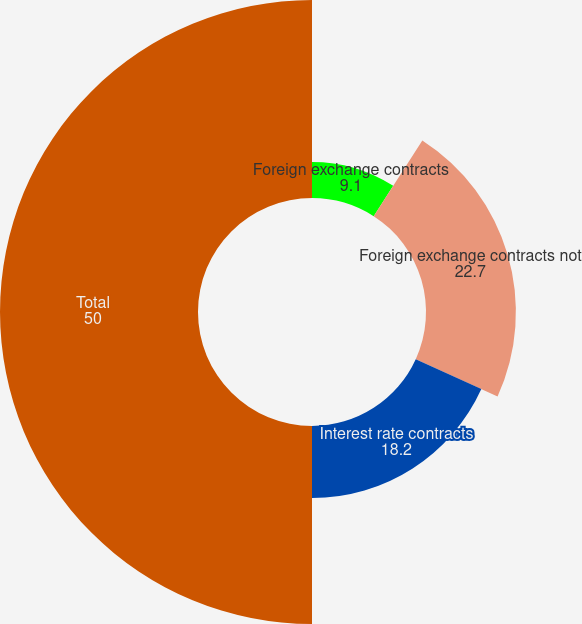Convert chart to OTSL. <chart><loc_0><loc_0><loc_500><loc_500><pie_chart><fcel>Foreign exchange contracts<fcel>Foreign exchange contracts not<fcel>Interest rate contracts<fcel>Total<nl><fcel>9.1%<fcel>22.7%<fcel>18.2%<fcel>50.0%<nl></chart> 